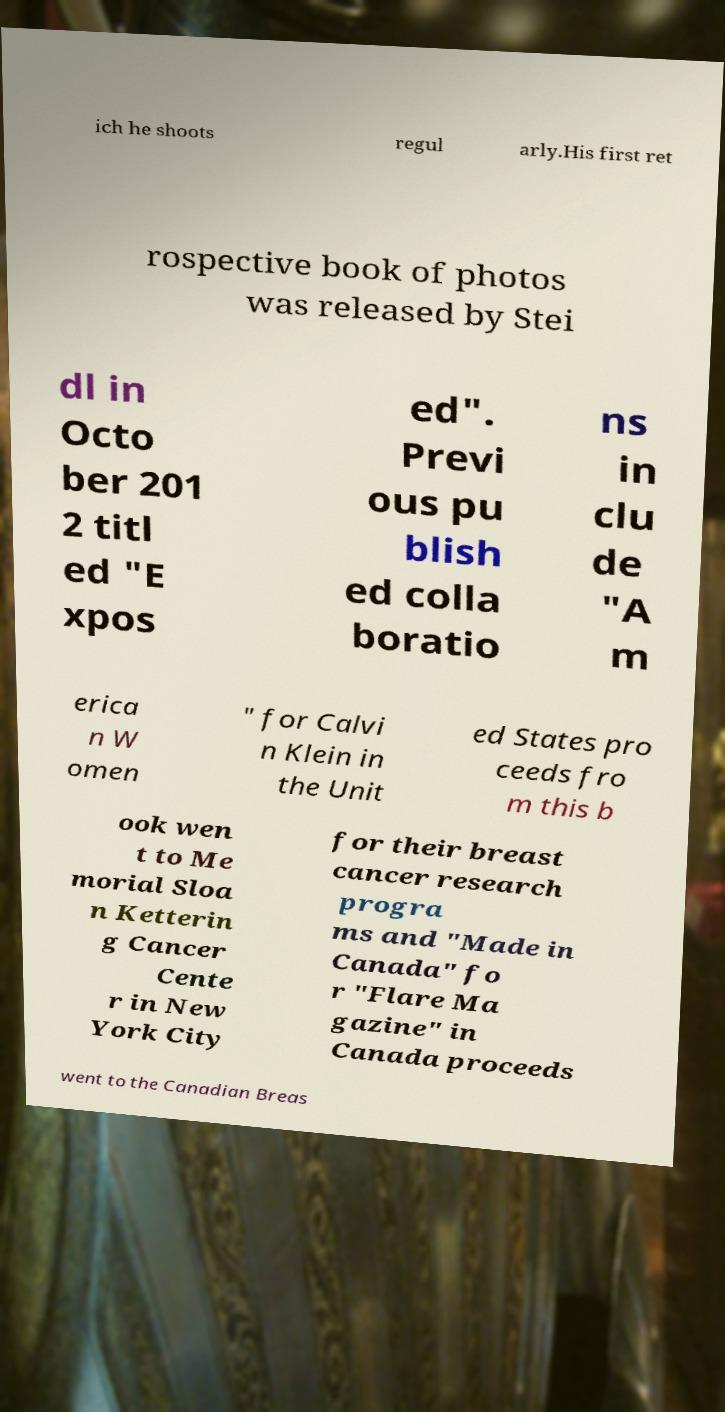Could you assist in decoding the text presented in this image and type it out clearly? ich he shoots regul arly.His first ret rospective book of photos was released by Stei dl in Octo ber 201 2 titl ed "E xpos ed". Previ ous pu blish ed colla boratio ns in clu de "A m erica n W omen " for Calvi n Klein in the Unit ed States pro ceeds fro m this b ook wen t to Me morial Sloa n Ketterin g Cancer Cente r in New York City for their breast cancer research progra ms and "Made in Canada" fo r "Flare Ma gazine" in Canada proceeds went to the Canadian Breas 